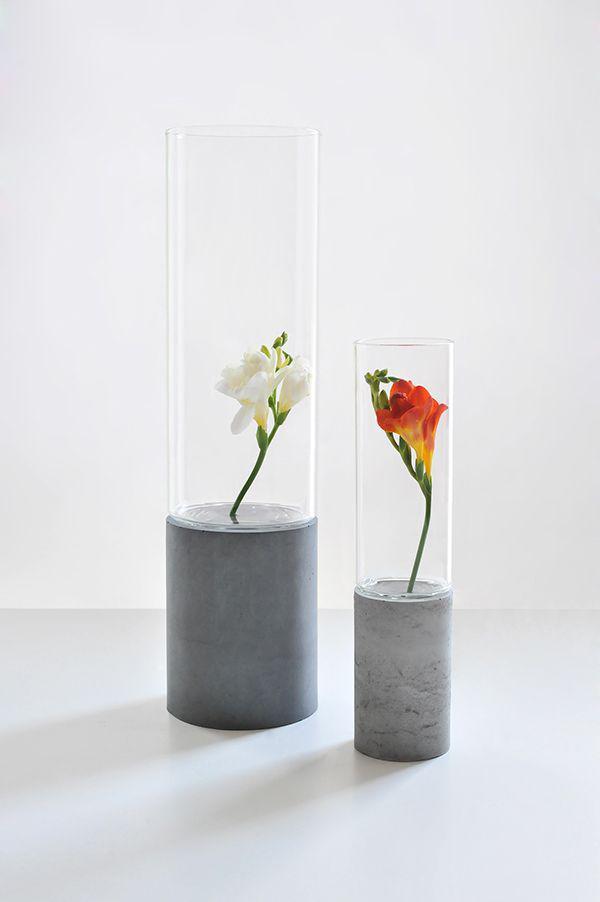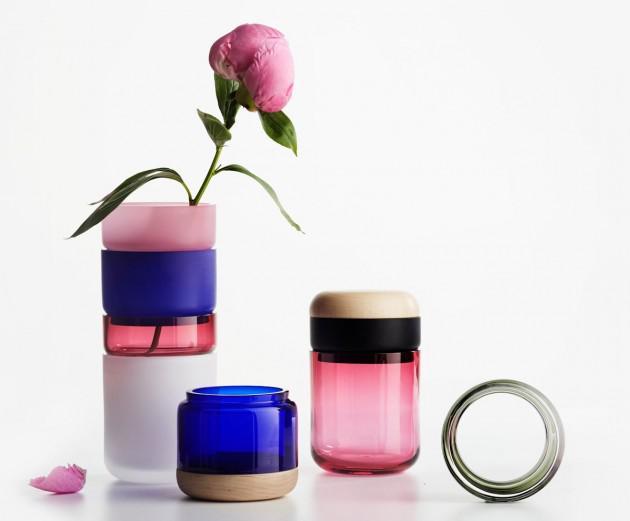The first image is the image on the left, the second image is the image on the right. Evaluate the accuracy of this statement regarding the images: "An image shows a jar with a flower in it.". Is it true? Answer yes or no. Yes. The first image is the image on the left, the second image is the image on the right. For the images displayed, is the sentence "The number of jars in one image without lids is the same number in the other image with lids." factually correct? Answer yes or no. No. 